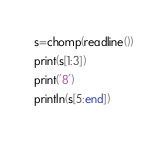Convert code to text. <code><loc_0><loc_0><loc_500><loc_500><_Julia_>s=chomp(readline())
print(s[1:3])
print('8')
println(s[5:end])</code> 